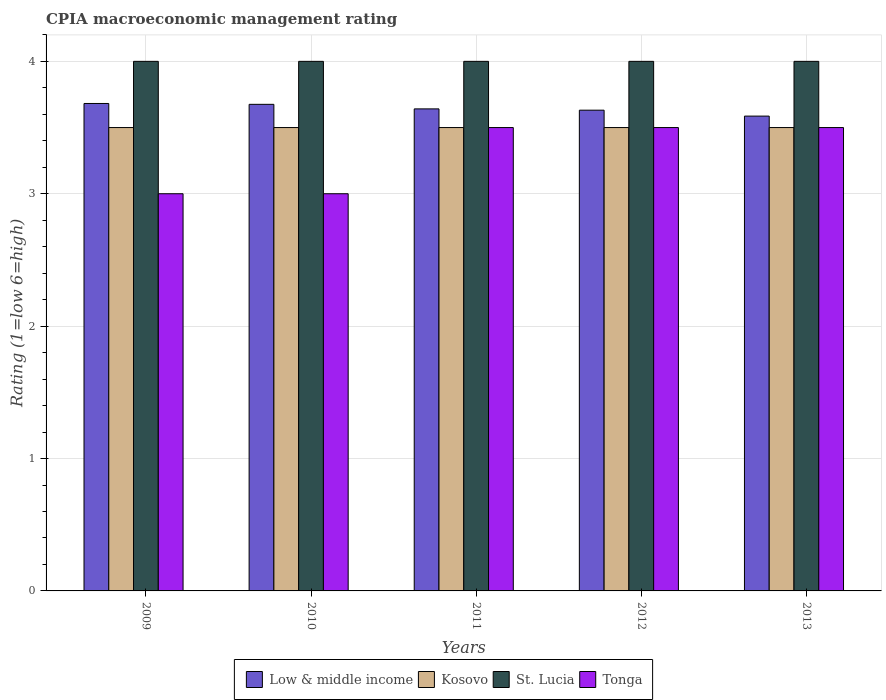How many different coloured bars are there?
Your answer should be compact. 4. How many groups of bars are there?
Ensure brevity in your answer.  5. How many bars are there on the 2nd tick from the left?
Make the answer very short. 4. How many bars are there on the 1st tick from the right?
Give a very brief answer. 4. What is the label of the 1st group of bars from the left?
Offer a terse response. 2009. In which year was the CPIA rating in Kosovo minimum?
Your answer should be very brief. 2009. What is the total CPIA rating in Low & middle income in the graph?
Provide a succinct answer. 18.22. What is the difference between the CPIA rating in Kosovo in 2009 and that in 2013?
Provide a succinct answer. 0. What is the difference between the CPIA rating in Low & middle income in 2012 and the CPIA rating in Kosovo in 2013?
Provide a short and direct response. 0.13. In the year 2010, what is the difference between the CPIA rating in Low & middle income and CPIA rating in St. Lucia?
Provide a succinct answer. -0.32. What is the ratio of the CPIA rating in Kosovo in 2009 to that in 2011?
Give a very brief answer. 1. Is the CPIA rating in Low & middle income in 2009 less than that in 2012?
Offer a very short reply. No. What is the difference between the highest and the second highest CPIA rating in Kosovo?
Ensure brevity in your answer.  0. What does the 4th bar from the left in 2012 represents?
Provide a short and direct response. Tonga. What does the 1st bar from the right in 2013 represents?
Keep it short and to the point. Tonga. Is it the case that in every year, the sum of the CPIA rating in Tonga and CPIA rating in Low & middle income is greater than the CPIA rating in Kosovo?
Offer a very short reply. Yes. How many years are there in the graph?
Offer a very short reply. 5. What is the difference between two consecutive major ticks on the Y-axis?
Give a very brief answer. 1. Are the values on the major ticks of Y-axis written in scientific E-notation?
Make the answer very short. No. Does the graph contain any zero values?
Offer a terse response. No. Does the graph contain grids?
Provide a succinct answer. Yes. Where does the legend appear in the graph?
Ensure brevity in your answer.  Bottom center. What is the title of the graph?
Offer a very short reply. CPIA macroeconomic management rating. Does "Djibouti" appear as one of the legend labels in the graph?
Offer a very short reply. No. What is the label or title of the X-axis?
Ensure brevity in your answer.  Years. What is the Rating (1=low 6=high) of Low & middle income in 2009?
Give a very brief answer. 3.68. What is the Rating (1=low 6=high) of Kosovo in 2009?
Keep it short and to the point. 3.5. What is the Rating (1=low 6=high) in St. Lucia in 2009?
Your response must be concise. 4. What is the Rating (1=low 6=high) in Tonga in 2009?
Offer a very short reply. 3. What is the Rating (1=low 6=high) of Low & middle income in 2010?
Offer a very short reply. 3.68. What is the Rating (1=low 6=high) of St. Lucia in 2010?
Provide a short and direct response. 4. What is the Rating (1=low 6=high) in Tonga in 2010?
Keep it short and to the point. 3. What is the Rating (1=low 6=high) in Low & middle income in 2011?
Provide a succinct answer. 3.64. What is the Rating (1=low 6=high) of Kosovo in 2011?
Provide a succinct answer. 3.5. What is the Rating (1=low 6=high) of St. Lucia in 2011?
Ensure brevity in your answer.  4. What is the Rating (1=low 6=high) of Tonga in 2011?
Make the answer very short. 3.5. What is the Rating (1=low 6=high) in Low & middle income in 2012?
Your answer should be compact. 3.63. What is the Rating (1=low 6=high) in Kosovo in 2012?
Provide a short and direct response. 3.5. What is the Rating (1=low 6=high) of St. Lucia in 2012?
Ensure brevity in your answer.  4. What is the Rating (1=low 6=high) of Low & middle income in 2013?
Make the answer very short. 3.59. What is the Rating (1=low 6=high) of Kosovo in 2013?
Your response must be concise. 3.5. What is the Rating (1=low 6=high) of St. Lucia in 2013?
Give a very brief answer. 4. Across all years, what is the maximum Rating (1=low 6=high) of Low & middle income?
Ensure brevity in your answer.  3.68. Across all years, what is the minimum Rating (1=low 6=high) in Low & middle income?
Offer a terse response. 3.59. Across all years, what is the minimum Rating (1=low 6=high) of Kosovo?
Ensure brevity in your answer.  3.5. Across all years, what is the minimum Rating (1=low 6=high) of St. Lucia?
Your answer should be very brief. 4. Across all years, what is the minimum Rating (1=low 6=high) of Tonga?
Give a very brief answer. 3. What is the total Rating (1=low 6=high) of Low & middle income in the graph?
Provide a short and direct response. 18.22. What is the total Rating (1=low 6=high) in Kosovo in the graph?
Keep it short and to the point. 17.5. What is the total Rating (1=low 6=high) in St. Lucia in the graph?
Make the answer very short. 20. What is the total Rating (1=low 6=high) in Tonga in the graph?
Give a very brief answer. 16.5. What is the difference between the Rating (1=low 6=high) in Low & middle income in 2009 and that in 2010?
Make the answer very short. 0.01. What is the difference between the Rating (1=low 6=high) of Kosovo in 2009 and that in 2010?
Make the answer very short. 0. What is the difference between the Rating (1=low 6=high) of St. Lucia in 2009 and that in 2010?
Give a very brief answer. 0. What is the difference between the Rating (1=low 6=high) in Low & middle income in 2009 and that in 2011?
Keep it short and to the point. 0.04. What is the difference between the Rating (1=low 6=high) in Kosovo in 2009 and that in 2011?
Your answer should be very brief. 0. What is the difference between the Rating (1=low 6=high) in St. Lucia in 2009 and that in 2011?
Provide a succinct answer. 0. What is the difference between the Rating (1=low 6=high) in Low & middle income in 2009 and that in 2012?
Offer a terse response. 0.05. What is the difference between the Rating (1=low 6=high) of St. Lucia in 2009 and that in 2012?
Provide a short and direct response. 0. What is the difference between the Rating (1=low 6=high) in Low & middle income in 2009 and that in 2013?
Make the answer very short. 0.1. What is the difference between the Rating (1=low 6=high) of St. Lucia in 2009 and that in 2013?
Your answer should be very brief. 0. What is the difference between the Rating (1=low 6=high) of Tonga in 2009 and that in 2013?
Ensure brevity in your answer.  -0.5. What is the difference between the Rating (1=low 6=high) of Low & middle income in 2010 and that in 2011?
Give a very brief answer. 0.03. What is the difference between the Rating (1=low 6=high) in St. Lucia in 2010 and that in 2011?
Give a very brief answer. 0. What is the difference between the Rating (1=low 6=high) in Tonga in 2010 and that in 2011?
Offer a very short reply. -0.5. What is the difference between the Rating (1=low 6=high) of Low & middle income in 2010 and that in 2012?
Provide a succinct answer. 0.04. What is the difference between the Rating (1=low 6=high) of Kosovo in 2010 and that in 2012?
Provide a short and direct response. 0. What is the difference between the Rating (1=low 6=high) in St. Lucia in 2010 and that in 2012?
Give a very brief answer. 0. What is the difference between the Rating (1=low 6=high) of Tonga in 2010 and that in 2012?
Ensure brevity in your answer.  -0.5. What is the difference between the Rating (1=low 6=high) of Low & middle income in 2010 and that in 2013?
Your answer should be compact. 0.09. What is the difference between the Rating (1=low 6=high) in Tonga in 2010 and that in 2013?
Your answer should be very brief. -0.5. What is the difference between the Rating (1=low 6=high) of Low & middle income in 2011 and that in 2012?
Make the answer very short. 0.01. What is the difference between the Rating (1=low 6=high) in Low & middle income in 2011 and that in 2013?
Keep it short and to the point. 0.05. What is the difference between the Rating (1=low 6=high) of Low & middle income in 2012 and that in 2013?
Offer a terse response. 0.04. What is the difference between the Rating (1=low 6=high) of St. Lucia in 2012 and that in 2013?
Ensure brevity in your answer.  0. What is the difference between the Rating (1=low 6=high) of Tonga in 2012 and that in 2013?
Your response must be concise. 0. What is the difference between the Rating (1=low 6=high) of Low & middle income in 2009 and the Rating (1=low 6=high) of Kosovo in 2010?
Your answer should be compact. 0.18. What is the difference between the Rating (1=low 6=high) of Low & middle income in 2009 and the Rating (1=low 6=high) of St. Lucia in 2010?
Ensure brevity in your answer.  -0.32. What is the difference between the Rating (1=low 6=high) in Low & middle income in 2009 and the Rating (1=low 6=high) in Tonga in 2010?
Offer a terse response. 0.68. What is the difference between the Rating (1=low 6=high) of Low & middle income in 2009 and the Rating (1=low 6=high) of Kosovo in 2011?
Offer a terse response. 0.18. What is the difference between the Rating (1=low 6=high) in Low & middle income in 2009 and the Rating (1=low 6=high) in St. Lucia in 2011?
Your response must be concise. -0.32. What is the difference between the Rating (1=low 6=high) in Low & middle income in 2009 and the Rating (1=low 6=high) in Tonga in 2011?
Offer a terse response. 0.18. What is the difference between the Rating (1=low 6=high) of Low & middle income in 2009 and the Rating (1=low 6=high) of Kosovo in 2012?
Offer a terse response. 0.18. What is the difference between the Rating (1=low 6=high) in Low & middle income in 2009 and the Rating (1=low 6=high) in St. Lucia in 2012?
Provide a short and direct response. -0.32. What is the difference between the Rating (1=low 6=high) in Low & middle income in 2009 and the Rating (1=low 6=high) in Tonga in 2012?
Keep it short and to the point. 0.18. What is the difference between the Rating (1=low 6=high) of St. Lucia in 2009 and the Rating (1=low 6=high) of Tonga in 2012?
Your response must be concise. 0.5. What is the difference between the Rating (1=low 6=high) in Low & middle income in 2009 and the Rating (1=low 6=high) in Kosovo in 2013?
Provide a short and direct response. 0.18. What is the difference between the Rating (1=low 6=high) in Low & middle income in 2009 and the Rating (1=low 6=high) in St. Lucia in 2013?
Your response must be concise. -0.32. What is the difference between the Rating (1=low 6=high) in Low & middle income in 2009 and the Rating (1=low 6=high) in Tonga in 2013?
Your answer should be very brief. 0.18. What is the difference between the Rating (1=low 6=high) of Kosovo in 2009 and the Rating (1=low 6=high) of St. Lucia in 2013?
Offer a very short reply. -0.5. What is the difference between the Rating (1=low 6=high) in Kosovo in 2009 and the Rating (1=low 6=high) in Tonga in 2013?
Give a very brief answer. 0. What is the difference between the Rating (1=low 6=high) of St. Lucia in 2009 and the Rating (1=low 6=high) of Tonga in 2013?
Your response must be concise. 0.5. What is the difference between the Rating (1=low 6=high) of Low & middle income in 2010 and the Rating (1=low 6=high) of Kosovo in 2011?
Make the answer very short. 0.18. What is the difference between the Rating (1=low 6=high) in Low & middle income in 2010 and the Rating (1=low 6=high) in St. Lucia in 2011?
Your answer should be very brief. -0.32. What is the difference between the Rating (1=low 6=high) of Low & middle income in 2010 and the Rating (1=low 6=high) of Tonga in 2011?
Provide a short and direct response. 0.18. What is the difference between the Rating (1=low 6=high) in Kosovo in 2010 and the Rating (1=low 6=high) in Tonga in 2011?
Keep it short and to the point. 0. What is the difference between the Rating (1=low 6=high) of Low & middle income in 2010 and the Rating (1=low 6=high) of Kosovo in 2012?
Offer a very short reply. 0.18. What is the difference between the Rating (1=low 6=high) of Low & middle income in 2010 and the Rating (1=low 6=high) of St. Lucia in 2012?
Offer a very short reply. -0.32. What is the difference between the Rating (1=low 6=high) of Low & middle income in 2010 and the Rating (1=low 6=high) of Tonga in 2012?
Keep it short and to the point. 0.18. What is the difference between the Rating (1=low 6=high) of Kosovo in 2010 and the Rating (1=low 6=high) of Tonga in 2012?
Ensure brevity in your answer.  0. What is the difference between the Rating (1=low 6=high) in Low & middle income in 2010 and the Rating (1=low 6=high) in Kosovo in 2013?
Give a very brief answer. 0.18. What is the difference between the Rating (1=low 6=high) of Low & middle income in 2010 and the Rating (1=low 6=high) of St. Lucia in 2013?
Offer a very short reply. -0.32. What is the difference between the Rating (1=low 6=high) of Low & middle income in 2010 and the Rating (1=low 6=high) of Tonga in 2013?
Keep it short and to the point. 0.18. What is the difference between the Rating (1=low 6=high) in Low & middle income in 2011 and the Rating (1=low 6=high) in Kosovo in 2012?
Your answer should be very brief. 0.14. What is the difference between the Rating (1=low 6=high) of Low & middle income in 2011 and the Rating (1=low 6=high) of St. Lucia in 2012?
Give a very brief answer. -0.36. What is the difference between the Rating (1=low 6=high) in Low & middle income in 2011 and the Rating (1=low 6=high) in Tonga in 2012?
Offer a very short reply. 0.14. What is the difference between the Rating (1=low 6=high) in Kosovo in 2011 and the Rating (1=low 6=high) in Tonga in 2012?
Your response must be concise. 0. What is the difference between the Rating (1=low 6=high) in Low & middle income in 2011 and the Rating (1=low 6=high) in Kosovo in 2013?
Offer a terse response. 0.14. What is the difference between the Rating (1=low 6=high) in Low & middle income in 2011 and the Rating (1=low 6=high) in St. Lucia in 2013?
Your answer should be very brief. -0.36. What is the difference between the Rating (1=low 6=high) in Low & middle income in 2011 and the Rating (1=low 6=high) in Tonga in 2013?
Give a very brief answer. 0.14. What is the difference between the Rating (1=low 6=high) in Low & middle income in 2012 and the Rating (1=low 6=high) in Kosovo in 2013?
Provide a short and direct response. 0.13. What is the difference between the Rating (1=low 6=high) of Low & middle income in 2012 and the Rating (1=low 6=high) of St. Lucia in 2013?
Provide a succinct answer. -0.37. What is the difference between the Rating (1=low 6=high) in Low & middle income in 2012 and the Rating (1=low 6=high) in Tonga in 2013?
Offer a very short reply. 0.13. What is the difference between the Rating (1=low 6=high) of Kosovo in 2012 and the Rating (1=low 6=high) of Tonga in 2013?
Make the answer very short. 0. What is the average Rating (1=low 6=high) in Low & middle income per year?
Provide a short and direct response. 3.64. What is the average Rating (1=low 6=high) of St. Lucia per year?
Ensure brevity in your answer.  4. In the year 2009, what is the difference between the Rating (1=low 6=high) in Low & middle income and Rating (1=low 6=high) in Kosovo?
Provide a short and direct response. 0.18. In the year 2009, what is the difference between the Rating (1=low 6=high) of Low & middle income and Rating (1=low 6=high) of St. Lucia?
Make the answer very short. -0.32. In the year 2009, what is the difference between the Rating (1=low 6=high) in Low & middle income and Rating (1=low 6=high) in Tonga?
Offer a terse response. 0.68. In the year 2010, what is the difference between the Rating (1=low 6=high) of Low & middle income and Rating (1=low 6=high) of Kosovo?
Give a very brief answer. 0.18. In the year 2010, what is the difference between the Rating (1=low 6=high) in Low & middle income and Rating (1=low 6=high) in St. Lucia?
Provide a short and direct response. -0.32. In the year 2010, what is the difference between the Rating (1=low 6=high) in Low & middle income and Rating (1=low 6=high) in Tonga?
Give a very brief answer. 0.68. In the year 2010, what is the difference between the Rating (1=low 6=high) in Kosovo and Rating (1=low 6=high) in St. Lucia?
Provide a succinct answer. -0.5. In the year 2010, what is the difference between the Rating (1=low 6=high) in Kosovo and Rating (1=low 6=high) in Tonga?
Provide a succinct answer. 0.5. In the year 2011, what is the difference between the Rating (1=low 6=high) in Low & middle income and Rating (1=low 6=high) in Kosovo?
Your response must be concise. 0.14. In the year 2011, what is the difference between the Rating (1=low 6=high) of Low & middle income and Rating (1=low 6=high) of St. Lucia?
Provide a short and direct response. -0.36. In the year 2011, what is the difference between the Rating (1=low 6=high) in Low & middle income and Rating (1=low 6=high) in Tonga?
Ensure brevity in your answer.  0.14. In the year 2011, what is the difference between the Rating (1=low 6=high) in St. Lucia and Rating (1=low 6=high) in Tonga?
Offer a terse response. 0.5. In the year 2012, what is the difference between the Rating (1=low 6=high) of Low & middle income and Rating (1=low 6=high) of Kosovo?
Provide a short and direct response. 0.13. In the year 2012, what is the difference between the Rating (1=low 6=high) in Low & middle income and Rating (1=low 6=high) in St. Lucia?
Provide a succinct answer. -0.37. In the year 2012, what is the difference between the Rating (1=low 6=high) of Low & middle income and Rating (1=low 6=high) of Tonga?
Make the answer very short. 0.13. In the year 2012, what is the difference between the Rating (1=low 6=high) in Kosovo and Rating (1=low 6=high) in St. Lucia?
Your answer should be compact. -0.5. In the year 2012, what is the difference between the Rating (1=low 6=high) of Kosovo and Rating (1=low 6=high) of Tonga?
Ensure brevity in your answer.  0. In the year 2012, what is the difference between the Rating (1=low 6=high) of St. Lucia and Rating (1=low 6=high) of Tonga?
Keep it short and to the point. 0.5. In the year 2013, what is the difference between the Rating (1=low 6=high) of Low & middle income and Rating (1=low 6=high) of Kosovo?
Offer a very short reply. 0.09. In the year 2013, what is the difference between the Rating (1=low 6=high) of Low & middle income and Rating (1=low 6=high) of St. Lucia?
Ensure brevity in your answer.  -0.41. In the year 2013, what is the difference between the Rating (1=low 6=high) of Low & middle income and Rating (1=low 6=high) of Tonga?
Give a very brief answer. 0.09. In the year 2013, what is the difference between the Rating (1=low 6=high) in Kosovo and Rating (1=low 6=high) in Tonga?
Your answer should be very brief. 0. In the year 2013, what is the difference between the Rating (1=low 6=high) in St. Lucia and Rating (1=low 6=high) in Tonga?
Ensure brevity in your answer.  0.5. What is the ratio of the Rating (1=low 6=high) of Kosovo in 2009 to that in 2010?
Your response must be concise. 1. What is the ratio of the Rating (1=low 6=high) of Tonga in 2009 to that in 2010?
Offer a terse response. 1. What is the ratio of the Rating (1=low 6=high) in Low & middle income in 2009 to that in 2011?
Provide a succinct answer. 1.01. What is the ratio of the Rating (1=low 6=high) in Low & middle income in 2009 to that in 2012?
Keep it short and to the point. 1.01. What is the ratio of the Rating (1=low 6=high) in Tonga in 2009 to that in 2012?
Your response must be concise. 0.86. What is the ratio of the Rating (1=low 6=high) in Low & middle income in 2009 to that in 2013?
Your response must be concise. 1.03. What is the ratio of the Rating (1=low 6=high) of Tonga in 2009 to that in 2013?
Offer a very short reply. 0.86. What is the ratio of the Rating (1=low 6=high) of Low & middle income in 2010 to that in 2011?
Keep it short and to the point. 1.01. What is the ratio of the Rating (1=low 6=high) of St. Lucia in 2010 to that in 2011?
Your response must be concise. 1. What is the ratio of the Rating (1=low 6=high) of Tonga in 2010 to that in 2011?
Offer a very short reply. 0.86. What is the ratio of the Rating (1=low 6=high) of Low & middle income in 2010 to that in 2012?
Your answer should be very brief. 1.01. What is the ratio of the Rating (1=low 6=high) of Low & middle income in 2010 to that in 2013?
Keep it short and to the point. 1.02. What is the ratio of the Rating (1=low 6=high) in Kosovo in 2010 to that in 2013?
Make the answer very short. 1. What is the ratio of the Rating (1=low 6=high) in Low & middle income in 2011 to that in 2012?
Provide a short and direct response. 1. What is the ratio of the Rating (1=low 6=high) of Kosovo in 2011 to that in 2012?
Ensure brevity in your answer.  1. What is the ratio of the Rating (1=low 6=high) of Tonga in 2011 to that in 2012?
Offer a terse response. 1. What is the ratio of the Rating (1=low 6=high) of Low & middle income in 2011 to that in 2013?
Give a very brief answer. 1.02. What is the ratio of the Rating (1=low 6=high) in Low & middle income in 2012 to that in 2013?
Give a very brief answer. 1.01. What is the difference between the highest and the second highest Rating (1=low 6=high) in Low & middle income?
Your response must be concise. 0.01. What is the difference between the highest and the second highest Rating (1=low 6=high) in Kosovo?
Make the answer very short. 0. What is the difference between the highest and the second highest Rating (1=low 6=high) in Tonga?
Offer a terse response. 0. What is the difference between the highest and the lowest Rating (1=low 6=high) in Low & middle income?
Provide a short and direct response. 0.1. What is the difference between the highest and the lowest Rating (1=low 6=high) of St. Lucia?
Make the answer very short. 0. 